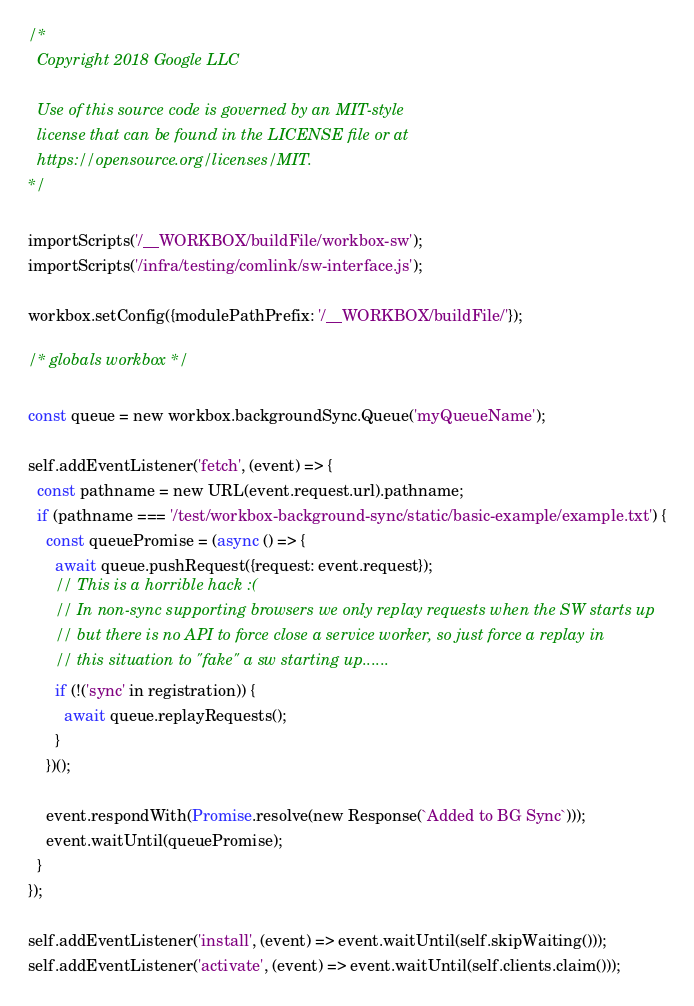Convert code to text. <code><loc_0><loc_0><loc_500><loc_500><_JavaScript_>/*
  Copyright 2018 Google LLC

  Use of this source code is governed by an MIT-style
  license that can be found in the LICENSE file or at
  https://opensource.org/licenses/MIT.
*/

importScripts('/__WORKBOX/buildFile/workbox-sw');
importScripts('/infra/testing/comlink/sw-interface.js');

workbox.setConfig({modulePathPrefix: '/__WORKBOX/buildFile/'});

/* globals workbox */

const queue = new workbox.backgroundSync.Queue('myQueueName');

self.addEventListener('fetch', (event) => {
  const pathname = new URL(event.request.url).pathname;
  if (pathname === '/test/workbox-background-sync/static/basic-example/example.txt') {
    const queuePromise = (async () => {
      await queue.pushRequest({request: event.request});
      // This is a horrible hack :(
      // In non-sync supporting browsers we only replay requests when the SW starts up
      // but there is no API to force close a service worker, so just force a replay in
      // this situation to "fake" a sw starting up......
      if (!('sync' in registration)) {
        await queue.replayRequests();
      }
    })();

    event.respondWith(Promise.resolve(new Response(`Added to BG Sync`)));
    event.waitUntil(queuePromise);
  }
});

self.addEventListener('install', (event) => event.waitUntil(self.skipWaiting()));
self.addEventListener('activate', (event) => event.waitUntil(self.clients.claim()));
</code> 